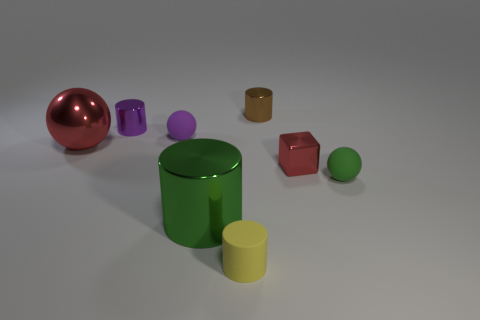Subtract 1 cylinders. How many cylinders are left? 3 Add 2 small blue rubber cylinders. How many objects exist? 10 Subtract all cubes. How many objects are left? 7 Subtract 0 gray cubes. How many objects are left? 8 Subtract all tiny red things. Subtract all metallic cylinders. How many objects are left? 4 Add 2 green shiny cylinders. How many green shiny cylinders are left? 3 Add 1 small red objects. How many small red objects exist? 2 